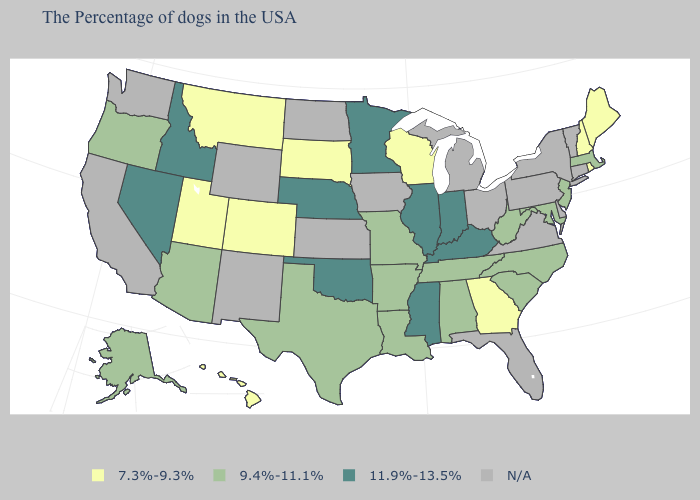Name the states that have a value in the range 9.4%-11.1%?
Keep it brief. Massachusetts, New Jersey, Maryland, North Carolina, South Carolina, West Virginia, Alabama, Tennessee, Louisiana, Missouri, Arkansas, Texas, Arizona, Oregon, Alaska. What is the lowest value in the West?
Answer briefly. 7.3%-9.3%. Which states have the lowest value in the USA?
Give a very brief answer. Maine, Rhode Island, New Hampshire, Georgia, Wisconsin, South Dakota, Colorado, Utah, Montana, Hawaii. Does the first symbol in the legend represent the smallest category?
Give a very brief answer. Yes. What is the value of Minnesota?
Write a very short answer. 11.9%-13.5%. Name the states that have a value in the range N/A?
Answer briefly. Vermont, Connecticut, New York, Delaware, Pennsylvania, Virginia, Ohio, Florida, Michigan, Iowa, Kansas, North Dakota, Wyoming, New Mexico, California, Washington. Does the map have missing data?
Short answer required. Yes. What is the lowest value in the USA?
Concise answer only. 7.3%-9.3%. Does Kentucky have the highest value in the South?
Quick response, please. Yes. How many symbols are there in the legend?
Answer briefly. 4. What is the value of Arizona?
Concise answer only. 9.4%-11.1%. Name the states that have a value in the range N/A?
Quick response, please. Vermont, Connecticut, New York, Delaware, Pennsylvania, Virginia, Ohio, Florida, Michigan, Iowa, Kansas, North Dakota, Wyoming, New Mexico, California, Washington. Among the states that border Ohio , does West Virginia have the lowest value?
Short answer required. Yes. Does the first symbol in the legend represent the smallest category?
Quick response, please. Yes. 